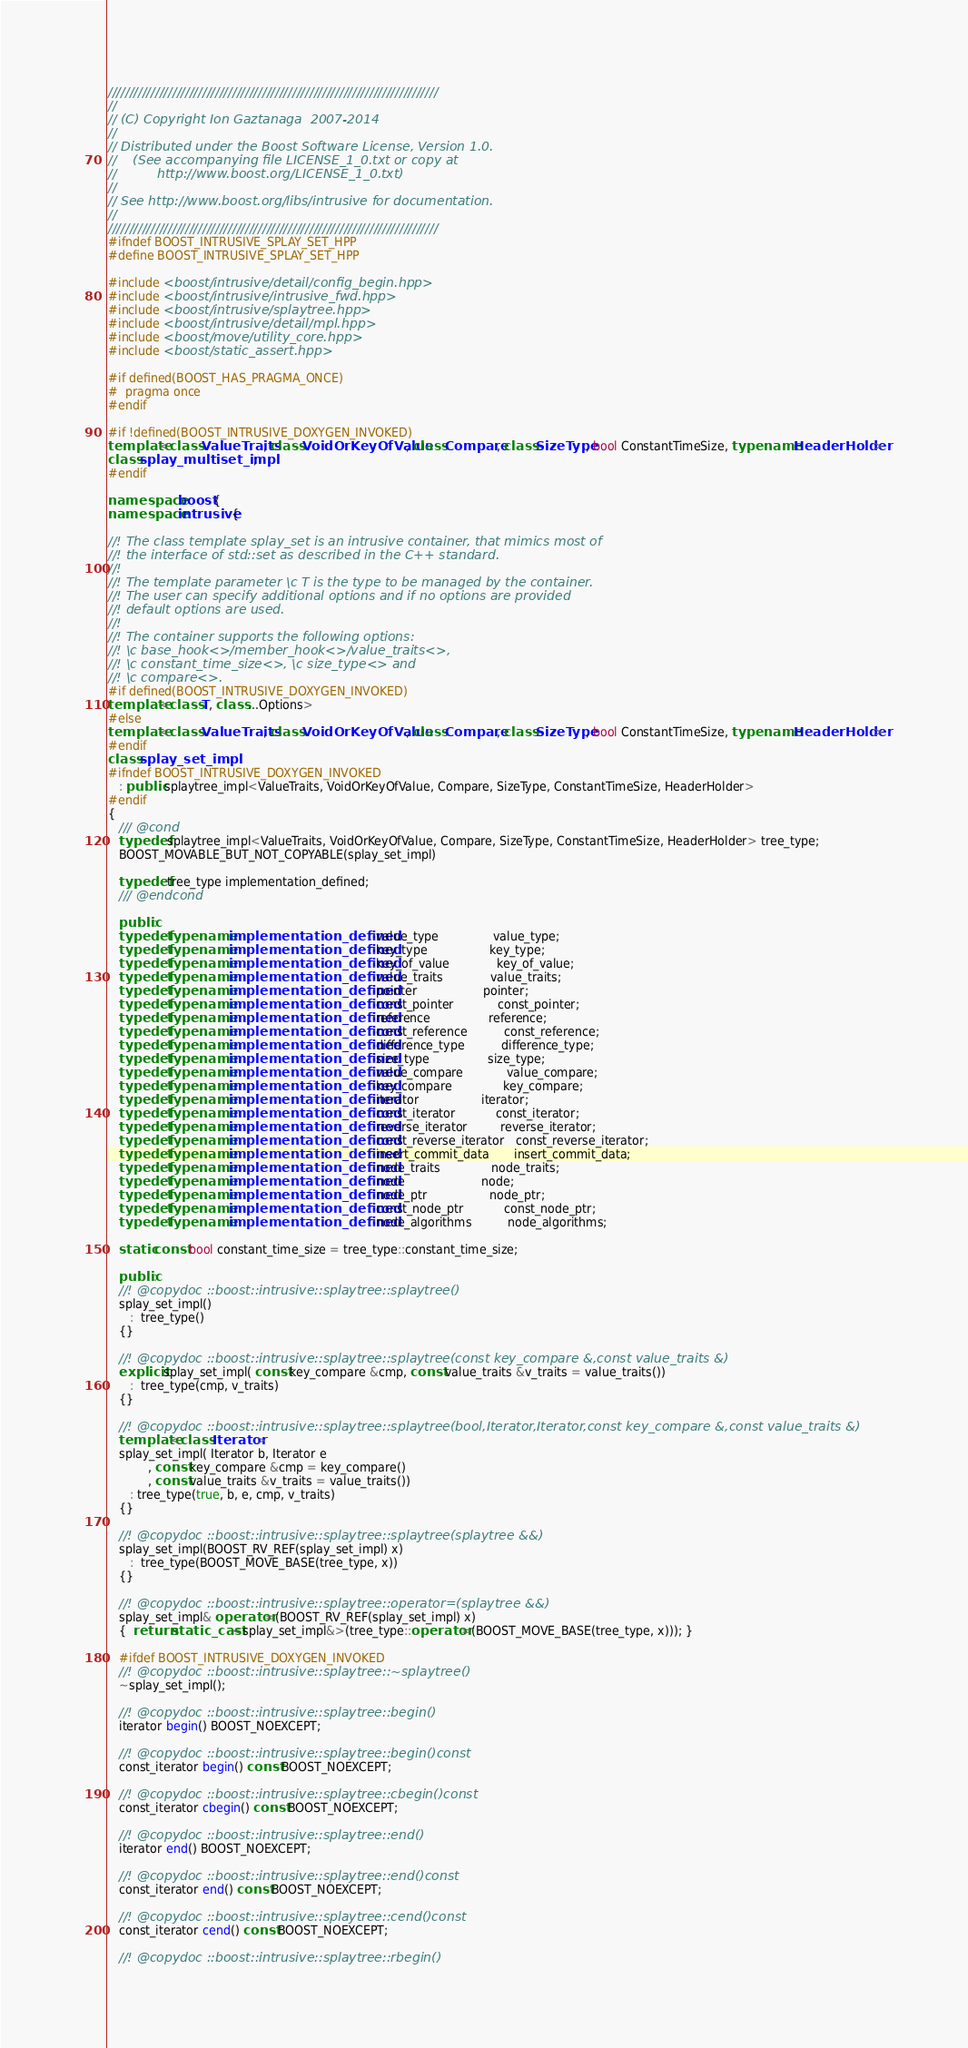Convert code to text. <code><loc_0><loc_0><loc_500><loc_500><_C++_>/////////////////////////////////////////////////////////////////////////////
//
// (C) Copyright Ion Gaztanaga  2007-2014
//
// Distributed under the Boost Software License, Version 1.0.
//    (See accompanying file LICENSE_1_0.txt or copy at
//          http://www.boost.org/LICENSE_1_0.txt)
//
// See http://www.boost.org/libs/intrusive for documentation.
//
/////////////////////////////////////////////////////////////////////////////
#ifndef BOOST_INTRUSIVE_SPLAY_SET_HPP
#define BOOST_INTRUSIVE_SPLAY_SET_HPP

#include <boost/intrusive/detail/config_begin.hpp>
#include <boost/intrusive/intrusive_fwd.hpp>
#include <boost/intrusive/splaytree.hpp>
#include <boost/intrusive/detail/mpl.hpp>
#include <boost/move/utility_core.hpp>
#include <boost/static_assert.hpp>

#if defined(BOOST_HAS_PRAGMA_ONCE)
#  pragma once
#endif

#if !defined(BOOST_INTRUSIVE_DOXYGEN_INVOKED)
template<class ValueTraits, class VoidOrKeyOfValue, class Compare, class SizeType, bool ConstantTimeSize, typename HeaderHolder>
class splay_multiset_impl;
#endif

namespace boost {
namespace intrusive {

//! The class template splay_set is an intrusive container, that mimics most of
//! the interface of std::set as described in the C++ standard.
//!
//! The template parameter \c T is the type to be managed by the container.
//! The user can specify additional options and if no options are provided
//! default options are used.
//!
//! The container supports the following options:
//! \c base_hook<>/member_hook<>/value_traits<>,
//! \c constant_time_size<>, \c size_type<> and
//! \c compare<>.
#if defined(BOOST_INTRUSIVE_DOXYGEN_INVOKED)
template<class T, class ...Options>
#else
template<class ValueTraits, class VoidOrKeyOfValue, class Compare, class SizeType, bool ConstantTimeSize, typename HeaderHolder>
#endif
class splay_set_impl
#ifndef BOOST_INTRUSIVE_DOXYGEN_INVOKED
   : public splaytree_impl<ValueTraits, VoidOrKeyOfValue, Compare, SizeType, ConstantTimeSize, HeaderHolder>
#endif
{
   /// @cond
   typedef splaytree_impl<ValueTraits, VoidOrKeyOfValue, Compare, SizeType, ConstantTimeSize, HeaderHolder> tree_type;
   BOOST_MOVABLE_BUT_NOT_COPYABLE(splay_set_impl)

   typedef tree_type implementation_defined;
   /// @endcond

   public:
   typedef typename implementation_defined::value_type               value_type;
   typedef typename implementation_defined::key_type                 key_type;
   typedef typename implementation_defined::key_of_value             key_of_value;
   typedef typename implementation_defined::value_traits             value_traits;
   typedef typename implementation_defined::pointer                  pointer;
   typedef typename implementation_defined::const_pointer            const_pointer;
   typedef typename implementation_defined::reference                reference;
   typedef typename implementation_defined::const_reference          const_reference;
   typedef typename implementation_defined::difference_type          difference_type;
   typedef typename implementation_defined::size_type                size_type;
   typedef typename implementation_defined::value_compare            value_compare;
   typedef typename implementation_defined::key_compare              key_compare;
   typedef typename implementation_defined::iterator                 iterator;
   typedef typename implementation_defined::const_iterator           const_iterator;
   typedef typename implementation_defined::reverse_iterator         reverse_iterator;
   typedef typename implementation_defined::const_reverse_iterator   const_reverse_iterator;
   typedef typename implementation_defined::insert_commit_data       insert_commit_data;
   typedef typename implementation_defined::node_traits              node_traits;
   typedef typename implementation_defined::node                     node;
   typedef typename implementation_defined::node_ptr                 node_ptr;
   typedef typename implementation_defined::const_node_ptr           const_node_ptr;
   typedef typename implementation_defined::node_algorithms          node_algorithms;

   static const bool constant_time_size = tree_type::constant_time_size;

   public:
   //! @copydoc ::boost::intrusive::splaytree::splaytree()
   splay_set_impl()
      :  tree_type()
   {}

   //! @copydoc ::boost::intrusive::splaytree::splaytree(const key_compare &,const value_traits &)
   explicit splay_set_impl( const key_compare &cmp, const value_traits &v_traits = value_traits())
      :  tree_type(cmp, v_traits)
   {}

   //! @copydoc ::boost::intrusive::splaytree::splaytree(bool,Iterator,Iterator,const key_compare &,const value_traits &)
   template<class Iterator>
   splay_set_impl( Iterator b, Iterator e
           , const key_compare &cmp = key_compare()
           , const value_traits &v_traits = value_traits())
      : tree_type(true, b, e, cmp, v_traits)
   {}

   //! @copydoc ::boost::intrusive::splaytree::splaytree(splaytree &&)
   splay_set_impl(BOOST_RV_REF(splay_set_impl) x)
      :  tree_type(BOOST_MOVE_BASE(tree_type, x))
   {}

   //! @copydoc ::boost::intrusive::splaytree::operator=(splaytree &&)
   splay_set_impl& operator=(BOOST_RV_REF(splay_set_impl) x)
   {  return static_cast<splay_set_impl&>(tree_type::operator=(BOOST_MOVE_BASE(tree_type, x))); }

   #ifdef BOOST_INTRUSIVE_DOXYGEN_INVOKED
   //! @copydoc ::boost::intrusive::splaytree::~splaytree()
   ~splay_set_impl();

   //! @copydoc ::boost::intrusive::splaytree::begin()
   iterator begin() BOOST_NOEXCEPT;

   //! @copydoc ::boost::intrusive::splaytree::begin()const
   const_iterator begin() const BOOST_NOEXCEPT;

   //! @copydoc ::boost::intrusive::splaytree::cbegin()const
   const_iterator cbegin() const BOOST_NOEXCEPT;

   //! @copydoc ::boost::intrusive::splaytree::end()
   iterator end() BOOST_NOEXCEPT;

   //! @copydoc ::boost::intrusive::splaytree::end()const
   const_iterator end() const BOOST_NOEXCEPT;

   //! @copydoc ::boost::intrusive::splaytree::cend()const
   const_iterator cend() const BOOST_NOEXCEPT;

   //! @copydoc ::boost::intrusive::splaytree::rbegin()</code> 